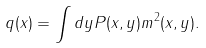Convert formula to latex. <formula><loc_0><loc_0><loc_500><loc_500>q ( x ) = \int d y P ( x , y ) m ^ { 2 } ( x , y ) .</formula> 